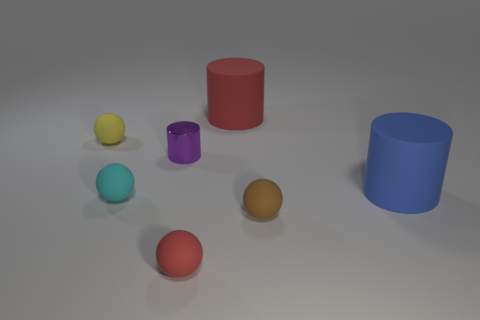Subtract all large blue cylinders. How many cylinders are left? 2 Add 2 small cyan metal balls. How many objects exist? 9 Subtract 3 cylinders. How many cylinders are left? 0 Subtract all cylinders. How many objects are left? 4 Subtract all brown balls. How many balls are left? 3 Subtract all brown objects. Subtract all large blue cylinders. How many objects are left? 5 Add 7 tiny brown objects. How many tiny brown objects are left? 8 Add 4 large red balls. How many large red balls exist? 4 Subtract 1 red cylinders. How many objects are left? 6 Subtract all gray cylinders. Subtract all blue balls. How many cylinders are left? 3 